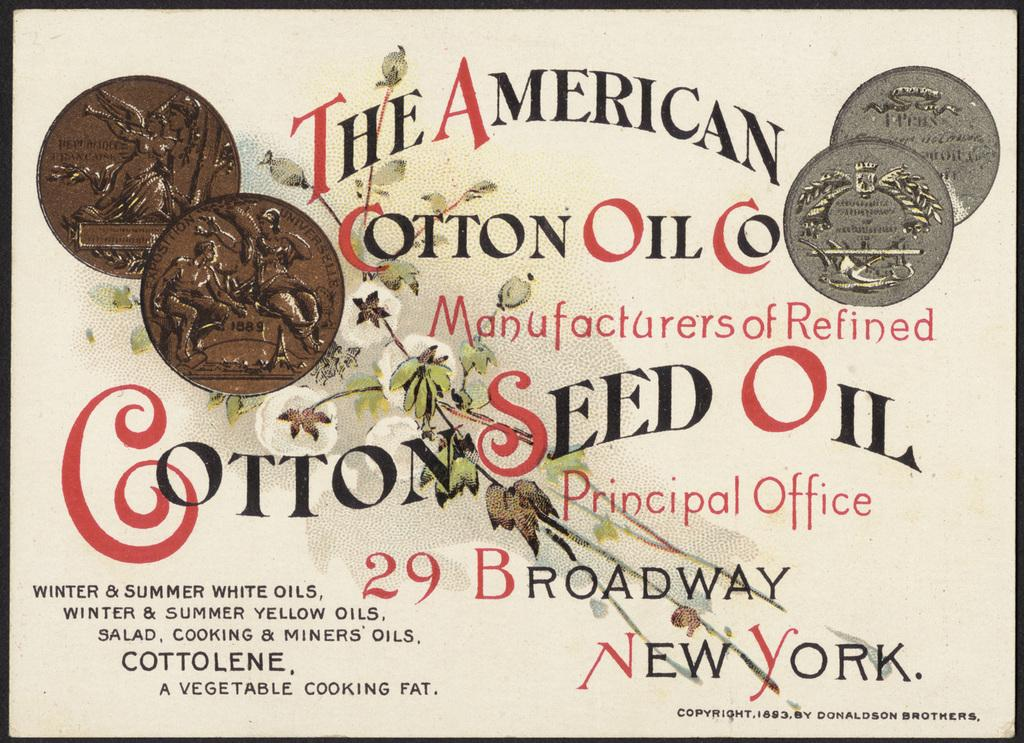<image>
Summarize the visual content of the image. An ad from 1893 for The American Cotton Oil Co. 